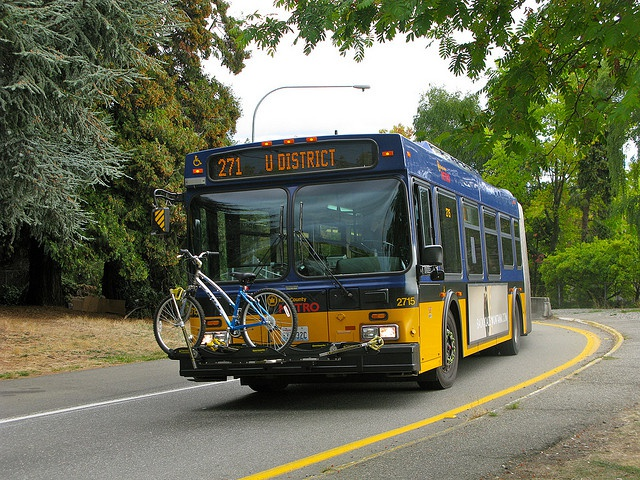Describe the objects in this image and their specific colors. I can see bus in darkgreen, black, gray, and olive tones and bicycle in darkgreen, black, olive, gray, and tan tones in this image. 